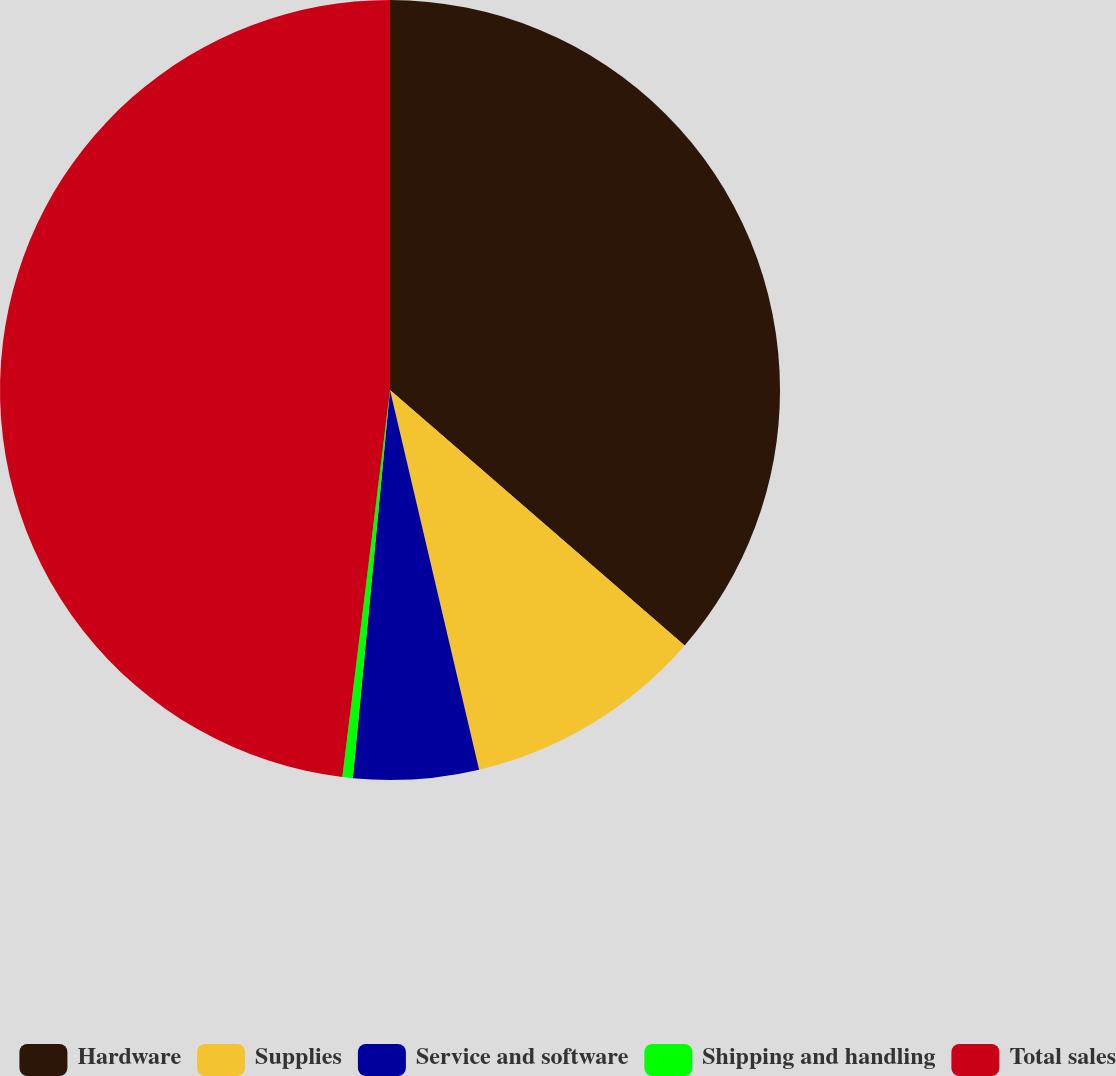Convert chart. <chart><loc_0><loc_0><loc_500><loc_500><pie_chart><fcel>Hardware<fcel>Supplies<fcel>Service and software<fcel>Shipping and handling<fcel>Total sales<nl><fcel>36.37%<fcel>9.96%<fcel>5.19%<fcel>0.43%<fcel>48.05%<nl></chart> 